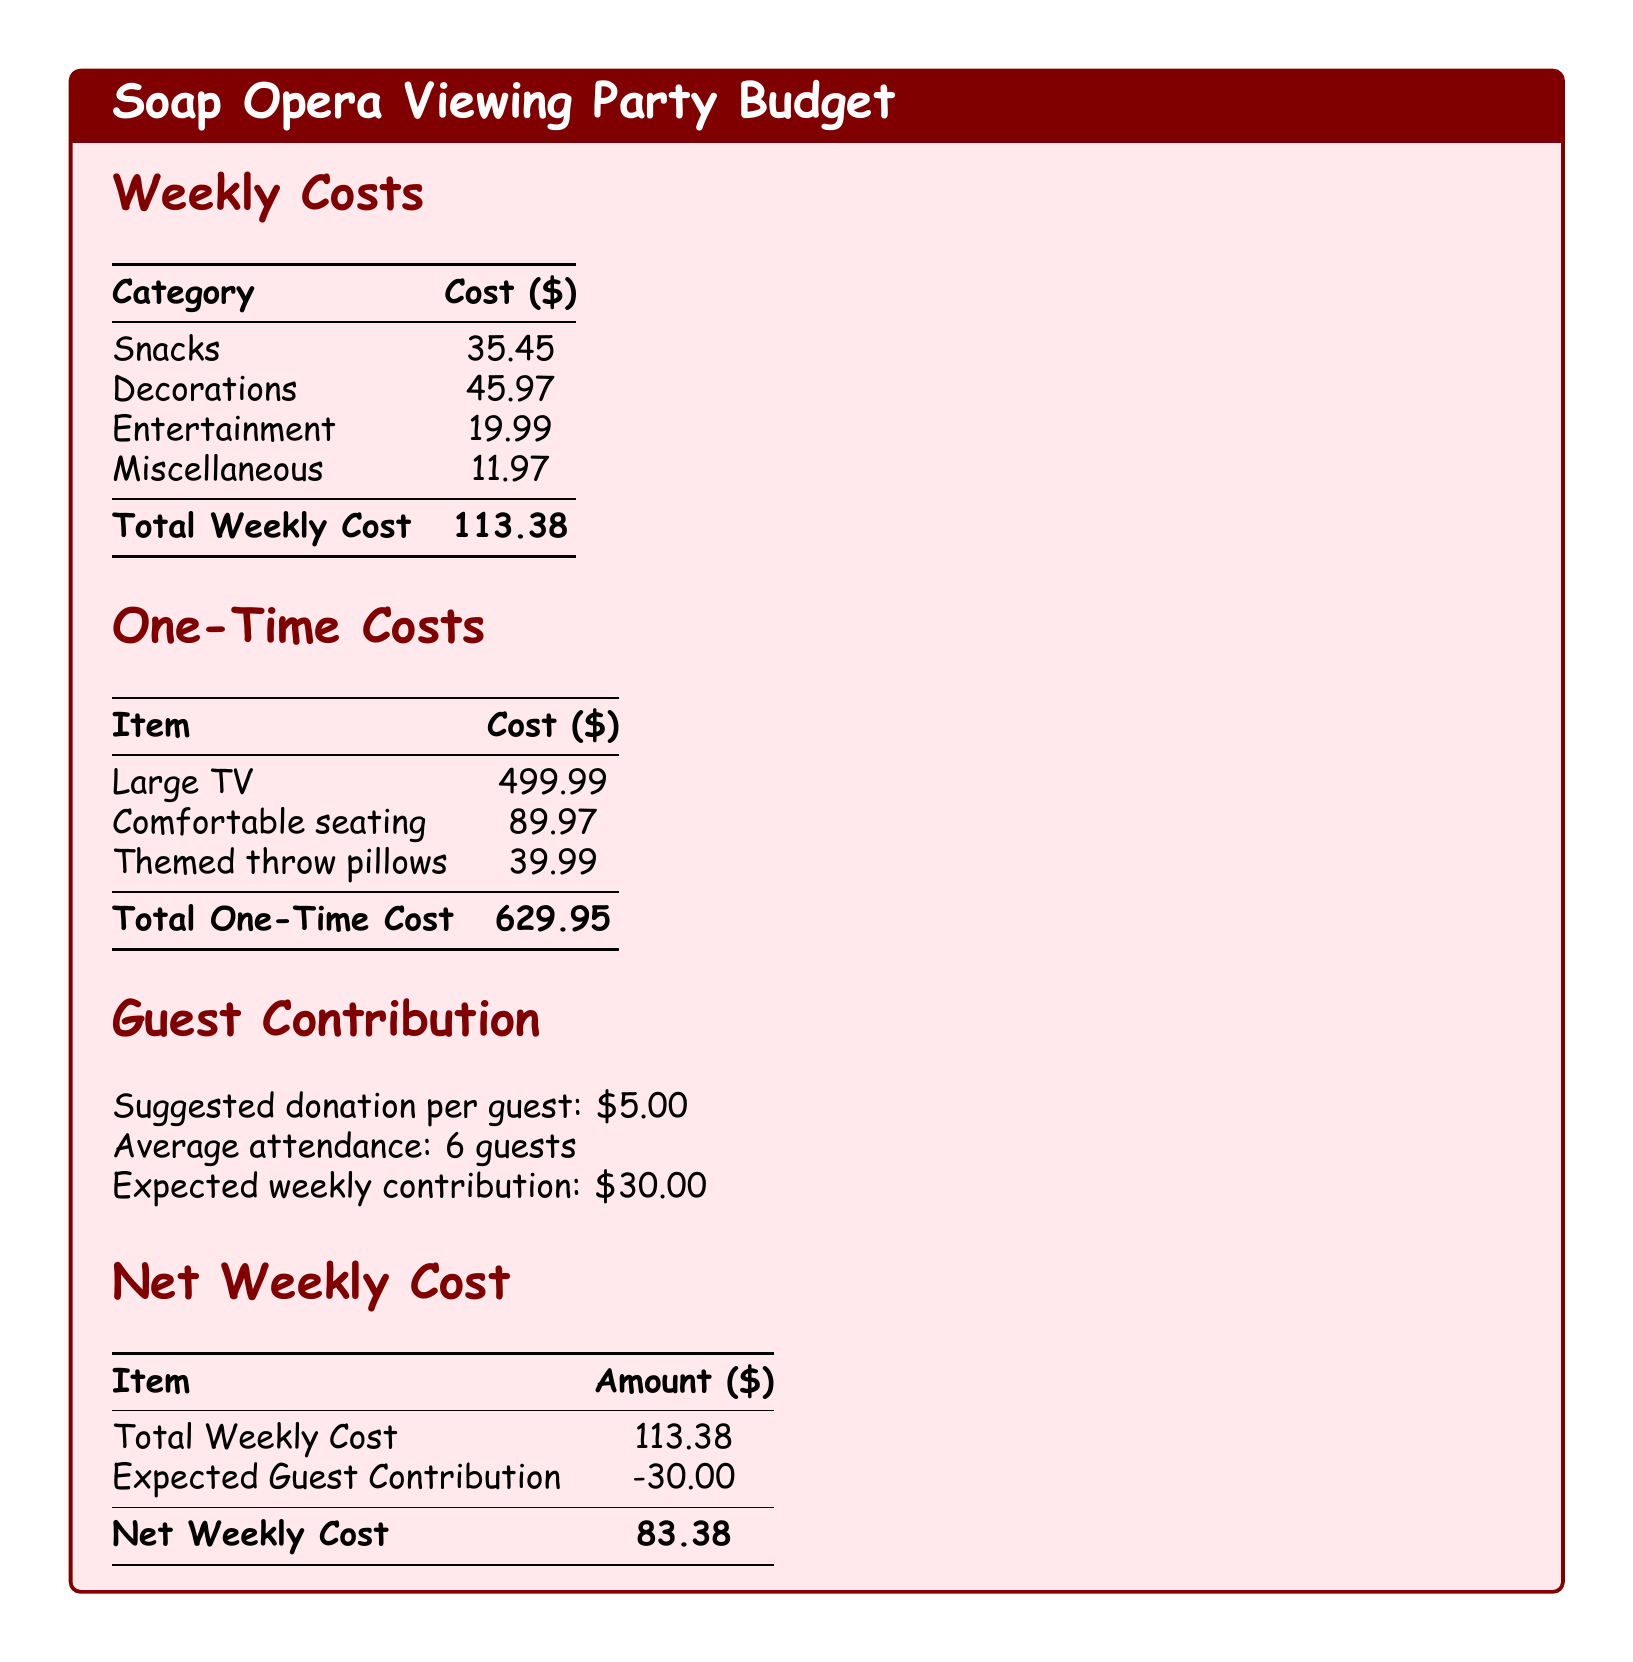What is the total weekly cost? The total weekly cost is the sum of all weekly costs including snacks, decorations, entertainment, and miscellaneous, which totals $113.38.
Answer: $113.38 What is the cost of decorations? The cost of decorations is listed in the document as $45.97.
Answer: $45.97 What is the total one-time cost? The total one-time cost is the sum of all one-time costs including the large TV, comfortable seating, and themed throw pillows, which amounts to $629.95.
Answer: $629.95 How many guests are expected on average? The document states the average attendance is 6 guests for the viewing party.
Answer: 6 guests What is the net weekly cost? The net weekly cost is calculated by subtracting the expected guest contribution from the total weekly cost, resulting in $83.38.
Answer: $83.38 What is the suggested donation per guest? The document specifies that the suggested donation per guest is $5.00.
Answer: $5.00 What is the cost for snacks? The document lists the cost for snacks as $35.45.
Answer: $35.45 How much is the entertainment cost? The entertainment cost detailed in the document is $19.99.
Answer: $19.99 What is the expected weekly contribution from guests? The expected weekly contribution from guests is derived from the number of guests and donation amount, totaling $30.00.
Answer: $30.00 